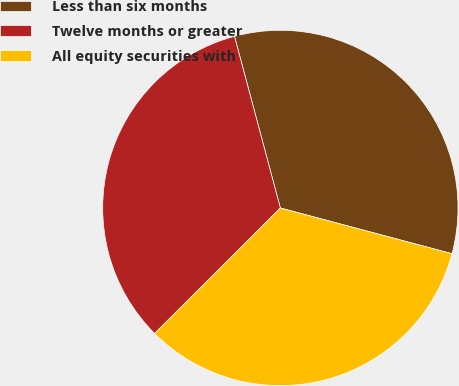<chart> <loc_0><loc_0><loc_500><loc_500><pie_chart><fcel>Less than six months<fcel>Twelve months or greater<fcel>All equity securities with<nl><fcel>33.3%<fcel>33.33%<fcel>33.37%<nl></chart> 